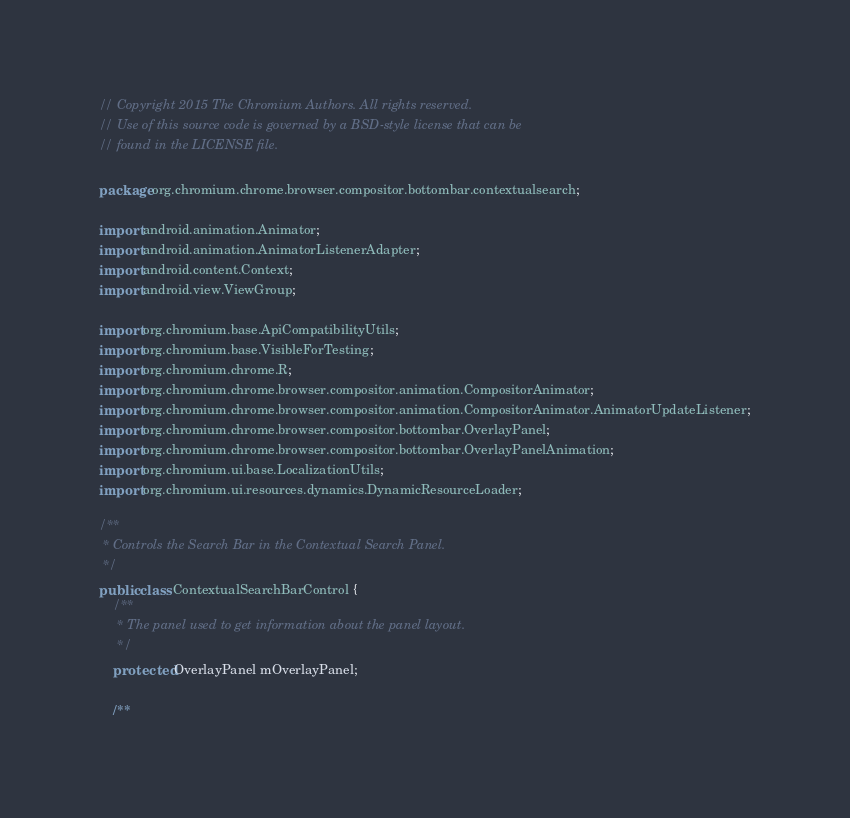<code> <loc_0><loc_0><loc_500><loc_500><_Java_>// Copyright 2015 The Chromium Authors. All rights reserved.
// Use of this source code is governed by a BSD-style license that can be
// found in the LICENSE file.

package org.chromium.chrome.browser.compositor.bottombar.contextualsearch;

import android.animation.Animator;
import android.animation.AnimatorListenerAdapter;
import android.content.Context;
import android.view.ViewGroup;

import org.chromium.base.ApiCompatibilityUtils;
import org.chromium.base.VisibleForTesting;
import org.chromium.chrome.R;
import org.chromium.chrome.browser.compositor.animation.CompositorAnimator;
import org.chromium.chrome.browser.compositor.animation.CompositorAnimator.AnimatorUpdateListener;
import org.chromium.chrome.browser.compositor.bottombar.OverlayPanel;
import org.chromium.chrome.browser.compositor.bottombar.OverlayPanelAnimation;
import org.chromium.ui.base.LocalizationUtils;
import org.chromium.ui.resources.dynamics.DynamicResourceLoader;

/**
 * Controls the Search Bar in the Contextual Search Panel.
 */
public class ContextualSearchBarControl {
    /**
     * The panel used to get information about the panel layout.
     */
    protected OverlayPanel mOverlayPanel;

    /**</code> 